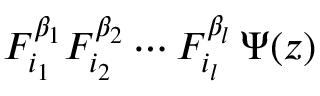<formula> <loc_0><loc_0><loc_500><loc_500>F _ { i _ { 1 } } ^ { \beta _ { 1 } } F _ { i _ { 2 } } ^ { \beta _ { 2 } } \cdots F _ { i _ { l } } ^ { \beta _ { l } } \, \Psi ( z )</formula> 